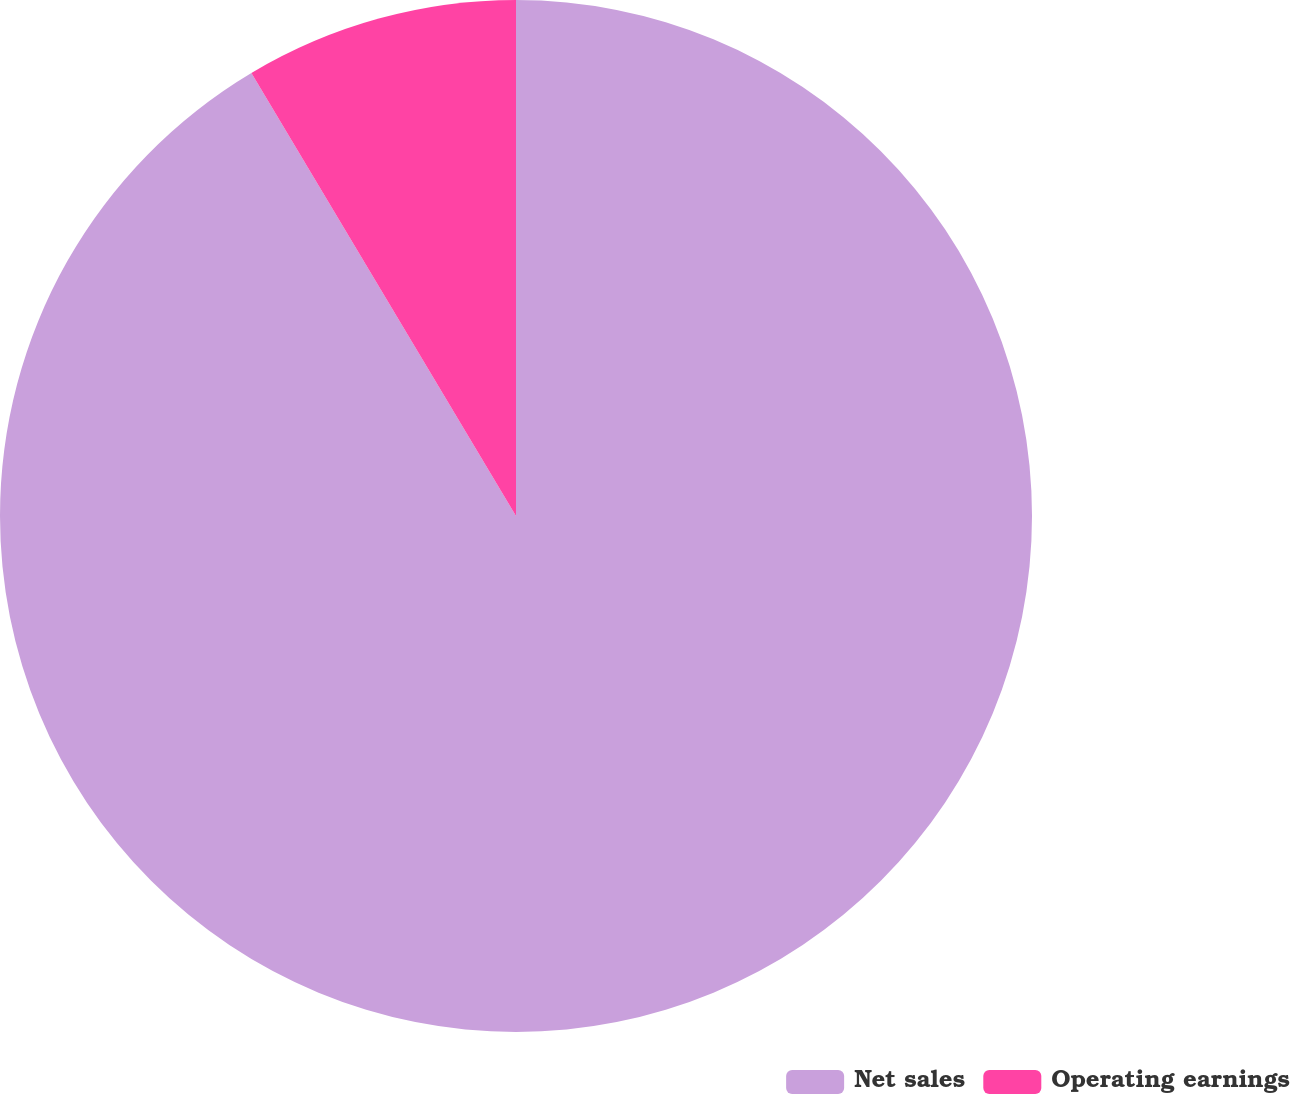Convert chart to OTSL. <chart><loc_0><loc_0><loc_500><loc_500><pie_chart><fcel>Net sales<fcel>Operating earnings<nl><fcel>91.43%<fcel>8.57%<nl></chart> 